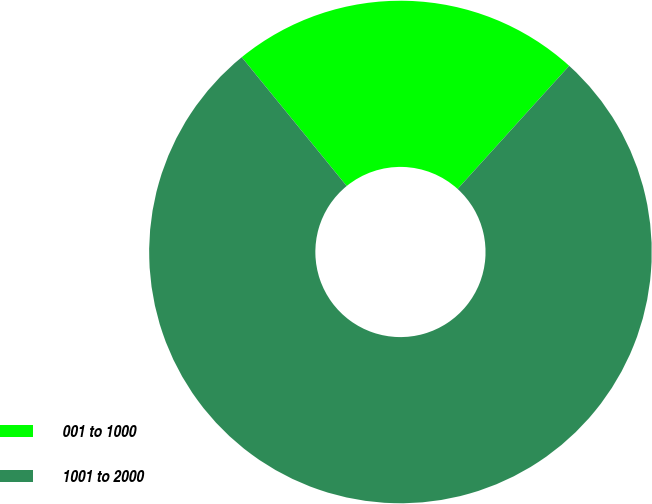Convert chart to OTSL. <chart><loc_0><loc_0><loc_500><loc_500><pie_chart><fcel>001 to 1000<fcel>1001 to 2000<nl><fcel>22.6%<fcel>77.4%<nl></chart> 